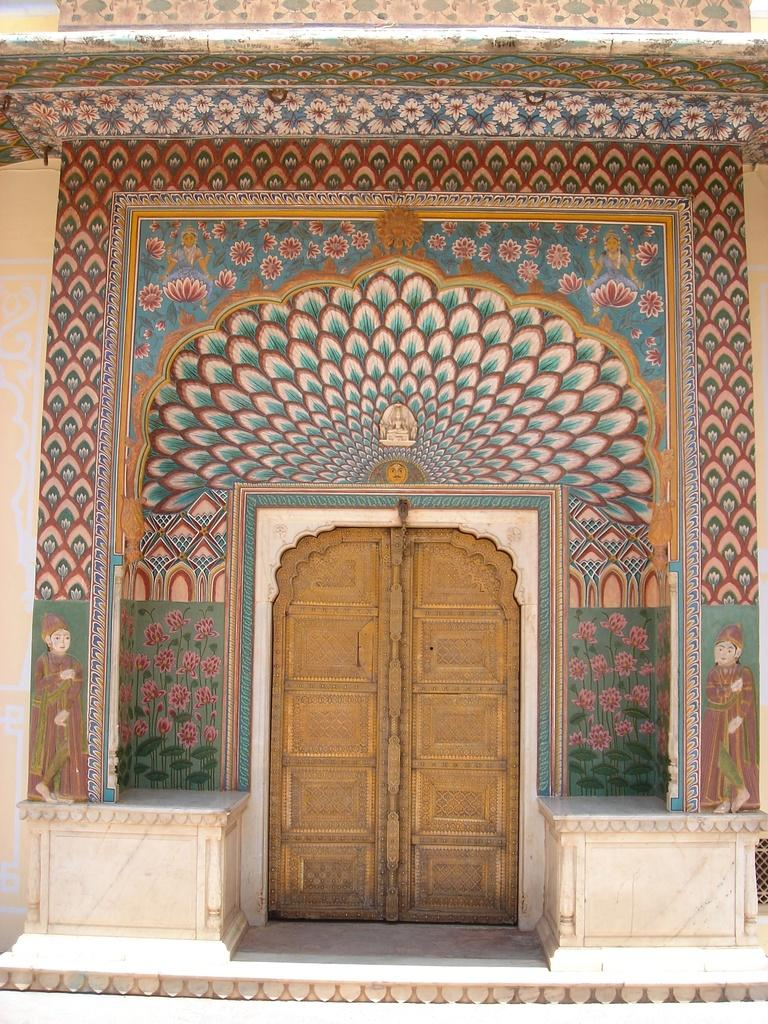What type of door is visible in the image? There is a wooden door in the image. What can be seen on the wall in the image? There is a painting on the wall in the image. How many kittens are playing with a quill in the image? There are no kittens or quills present in the image. What stage of development is depicted in the painting? The provided facts do not mention any specific stage of development in the painting, so it cannot be determined from the image. 